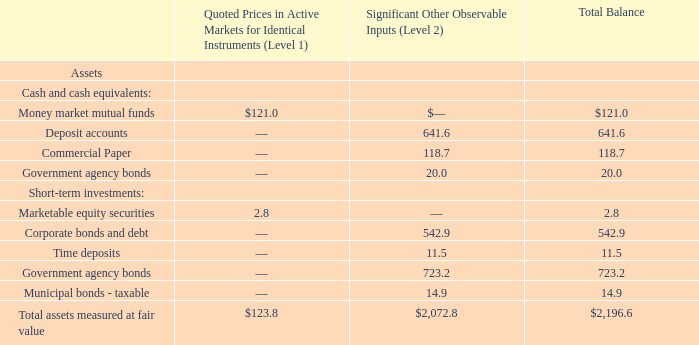Assets Measured at Fair Value on a Recurring Basis
Assets measured at fair value on a recurring basis at March 31, 2018 are as follows (amounts in millions):
There were no transfers between Level 1 or Level 2 during fiscal 2019 or fiscal 2018. There were no assets measured on a recurring basis during fiscal 2019 or fiscal 2018 using significant unobservable inputs (Level 3).
What was the total balance for Money market mutual funds?
Answer scale should be: million. 121.0. What was the total balance amount of deposit accounts?
Answer scale should be: million. 641.6. What was the total balance time deposits?
Answer scale should be: million. 11.5. What was the difference in the total balance between Money market mutual funds and commercial paper?
Answer scale should be: million. 121.0-118.7
Answer: 2.3. How many Short-term investments had a total balance that exceeded $500 million? Corporate bonds and debt##Government agency bonds
Answer: 2. What was the total balance amount of short-term Government agency bonds as a percentage of the total balance of assets?
Answer scale should be: percent. 723.2/2,196.6
Answer: 32.92. 